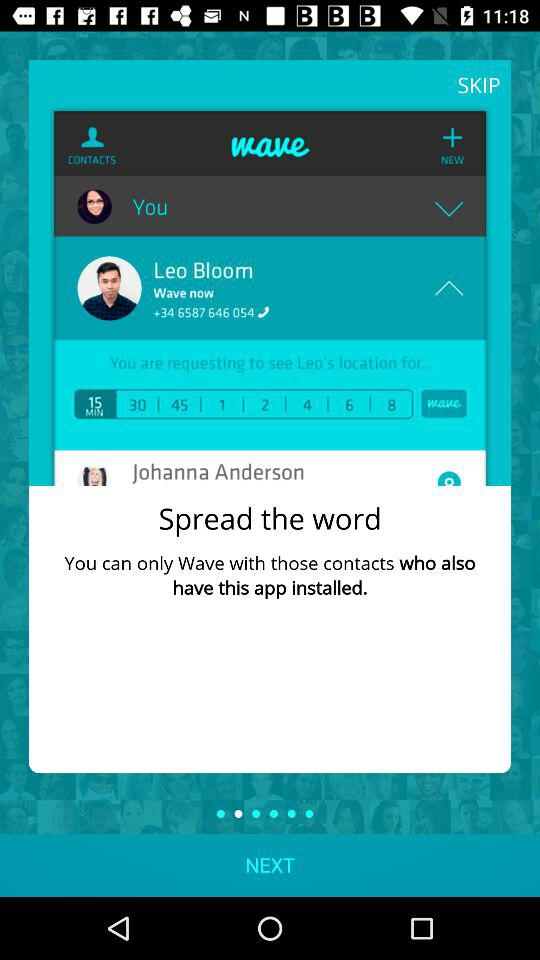How many more minutes are there in the 8 minute option than the 1 minute option?
Answer the question using a single word or phrase. 7 